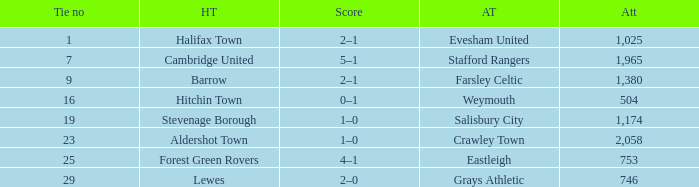How many attended tie number 19? 1174.0. 